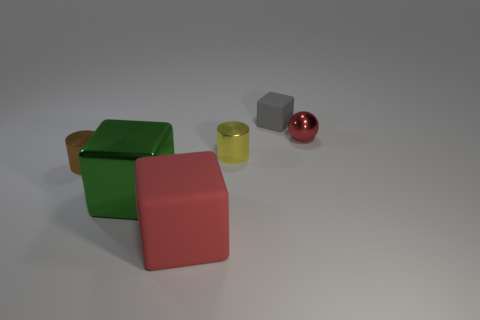Add 1 tiny gray metal cylinders. How many objects exist? 7 Subtract all green blocks. How many blocks are left? 2 Subtract all big blocks. How many blocks are left? 1 Subtract 0 purple cylinders. How many objects are left? 6 Subtract all spheres. How many objects are left? 5 Subtract 1 cubes. How many cubes are left? 2 Subtract all brown cubes. Subtract all gray cylinders. How many cubes are left? 3 Subtract all green balls. How many brown cubes are left? 0 Subtract all metal things. Subtract all purple shiny cylinders. How many objects are left? 2 Add 2 small brown shiny cylinders. How many small brown shiny cylinders are left? 3 